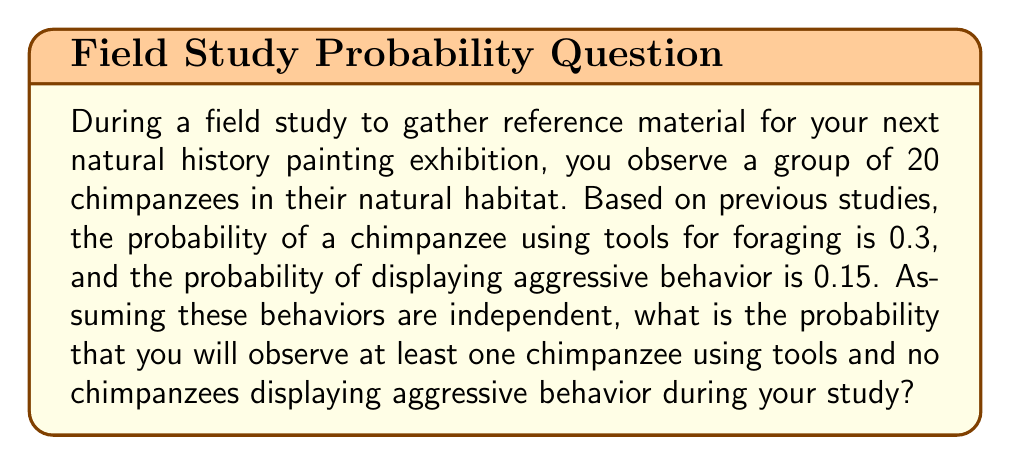Teach me how to tackle this problem. Let's approach this step-by-step:

1) First, we need to calculate the probability of observing at least one chimpanzee using tools:
   P(at least one using tools) = 1 - P(no chimpanzees using tools)
   $$ P(\text{at least one using tools}) = 1 - (1-0.3)^{20} = 1 - 0.7^{20} \approx 0.9988 $$

2) Next, we calculate the probability of observing no aggressive behavior:
   $$ P(\text{no aggressive behavior}) = (1-0.15)^{20} = 0.85^{20} \approx 0.0388 $$

3) Since these events are independent, we multiply these probabilities:
   $$ P(\text{at least one using tools AND no aggressive behavior}) = 0.9988 \times 0.0388 \approx 0.0388 $$

4) Convert to a percentage:
   $$ 0.0388 \times 100\% = 3.88\% $$
Answer: 3.88% 